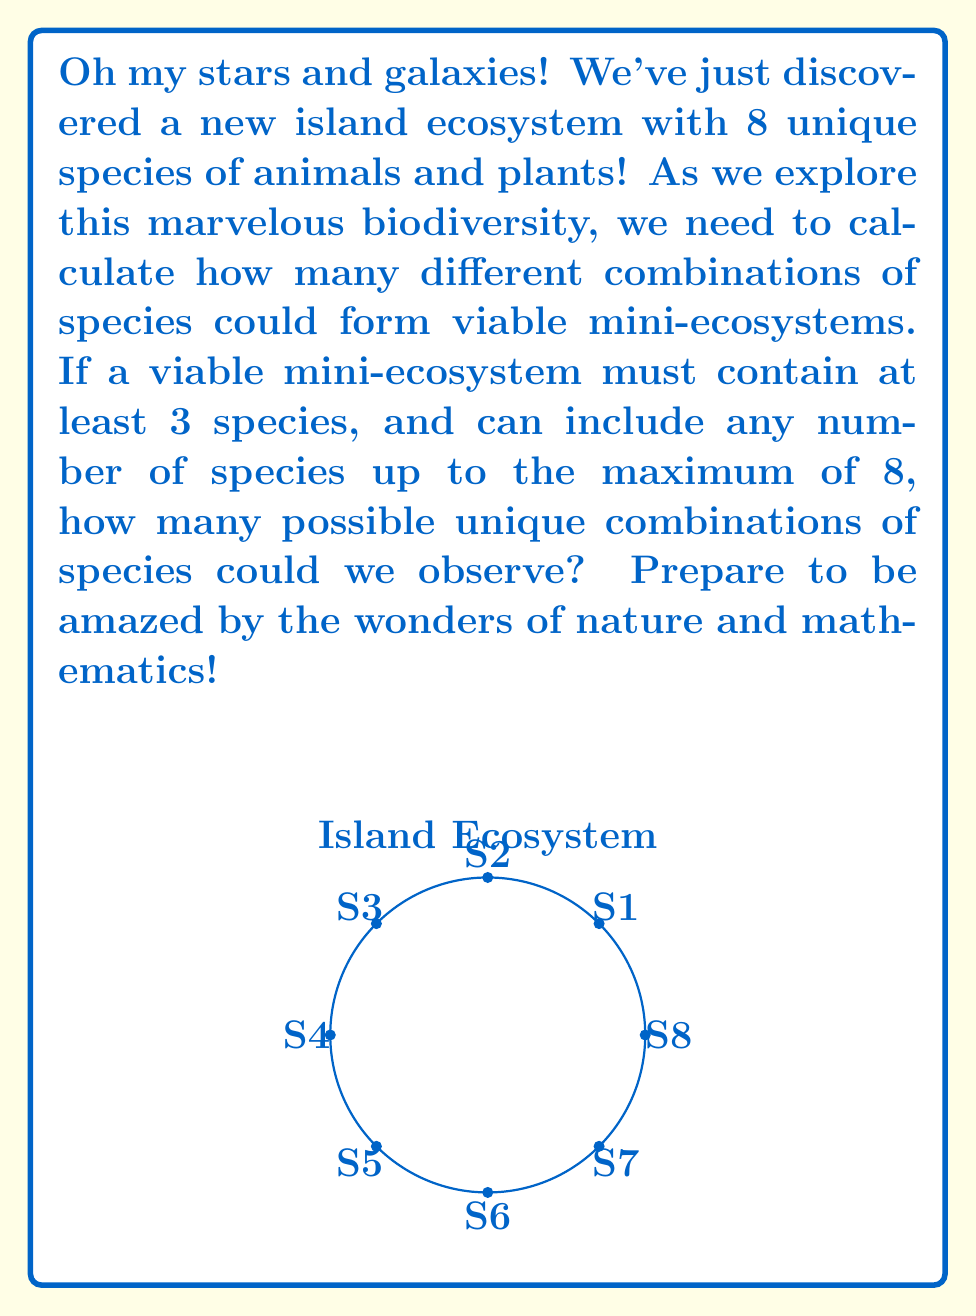What is the answer to this math problem? Let's approach this step-by-step, embracing the excitement of discovery!

1) We need to consider all combinations with 3, 4, 5, 6, 7, and 8 species.

2) For each of these, we use the combination formula:
   $${n \choose k} = \frac{n!}{k!(n-k)!}$$
   where $n$ is the total number of species (8) and $k$ is the number in each combination.

3) Let's calculate each:

   For 3 species: $${8 \choose 3} = \frac{8!}{3!(8-3)!} = \frac{8!}{3!5!} = 56$$

   For 4 species: $${8 \choose 4} = \frac{8!}{4!(8-4)!} = \frac{8!}{4!4!} = 70$$

   For 5 species: $${8 \choose 5} = \frac{8!}{5!(8-5)!} = \frac{8!}{5!3!} = 56$$

   For 6 species: $${8 \choose 6} = \frac{8!}{6!(8-6)!} = \frac{8!}{6!2!} = 28$$

   For 7 species: $${8 \choose 7} = \frac{8!}{7!(8-7)!} = \frac{8!}{7!1!} = 8$$

   For 8 species: $${8 \choose 8} = \frac{8!}{8!(8-8)!} = \frac{8!}{8!0!} = 1$$

4) The total number of combinations is the sum of all these:

   $$56 + 70 + 56 + 28 + 8 + 1 = 219$$

Isn't it incredible how many potential ecosystems could exist with just 8 species? Nature's complexity never ceases to amaze!
Answer: 219 